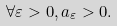Convert formula to latex. <formula><loc_0><loc_0><loc_500><loc_500>\forall \varepsilon > 0 , a _ { \varepsilon } > 0 .</formula> 